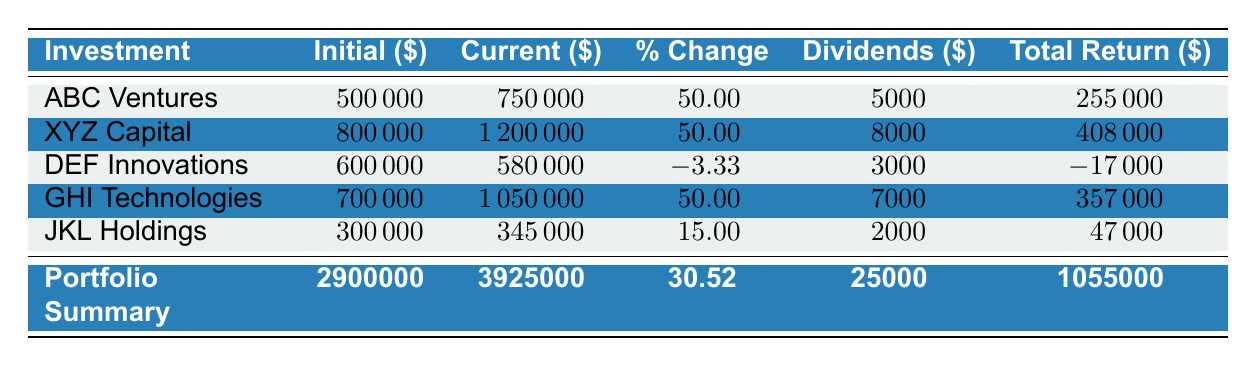What is the initial investment amount for XYZ Capital? The table shows the investment details for each company, and for XYZ Capital, the corresponding value in the "Initial ($)" column is 800000.
Answer: 800000 What is the total current value of all investments? To find the total current value, we sum up the "Current ($)" values from each investment: 750000 + 1200000 + 580000 + 1050000 + 345000 = 3925000.
Answer: 3925000 Is the total return from DEF Innovations positive? The table shows that the total return for DEF Innovations is -17000, which is a negative value. Therefore, the statement is false.
Answer: No What is the average percent change across all investments? The average percent change is given in the portfolio summary as 30.52. This value is already calculated by averaging the percent changes of all individual investments.
Answer: 30.52 How much total dividends were received from the investments? The total dividends received from all investments can be found in the portfolio summary under "Total Dividends ($)" which is listed as 25000.
Answer: 25000 Which investment generated the highest total return? By examining the "Total Return ($)" column, the highest value is 408000 from XYZ Capital.
Answer: XYZ Capital If the total initial investment was 2900000, what is the percentage increase in value of the portfolio? To calculate the percentage increase, use the formula: ((total current value - total initial investment) / total initial investment) * 100. Plugging in the values gives: ((3925000 - 2900000) / 2900000) * 100 = 35.14%.
Answer: 35.14 Is the total initial investment higher than the total current value? The total initial investment is 2900000 and the total current value is 3925000. Since 2900000 is less than 3925000, the statement is false.
Answer: No How much was lost on the DEF Innovations investment? The loss can be identified from the "Total Return ($)" column for DEF Innovations, which shows -17000. This indicates a loss of 17000.
Answer: 17000 